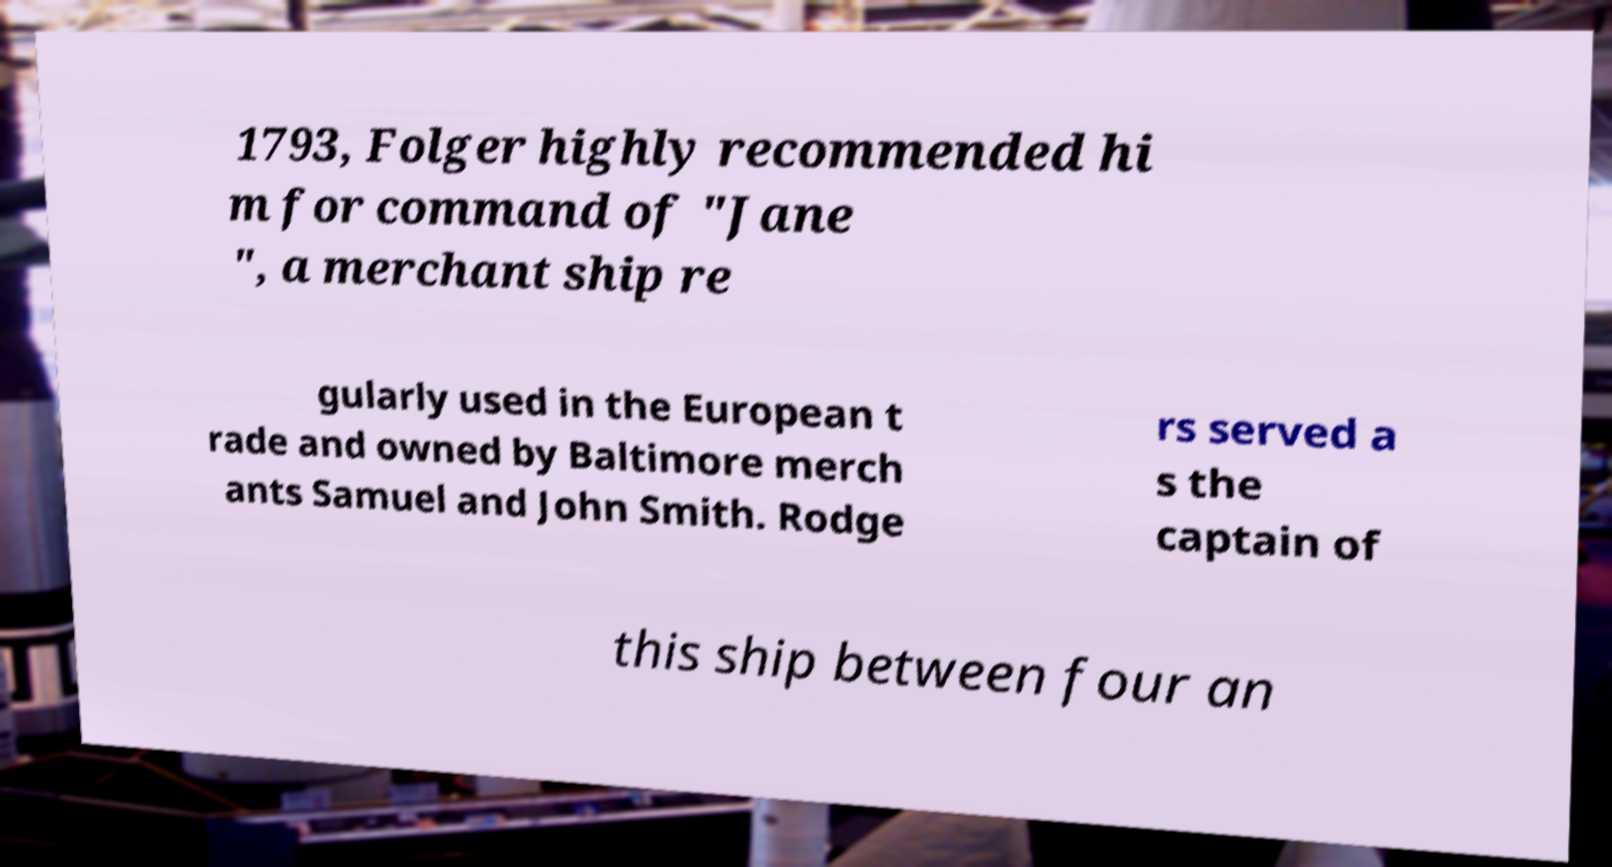For documentation purposes, I need the text within this image transcribed. Could you provide that? 1793, Folger highly recommended hi m for command of "Jane ", a merchant ship re gularly used in the European t rade and owned by Baltimore merch ants Samuel and John Smith. Rodge rs served a s the captain of this ship between four an 